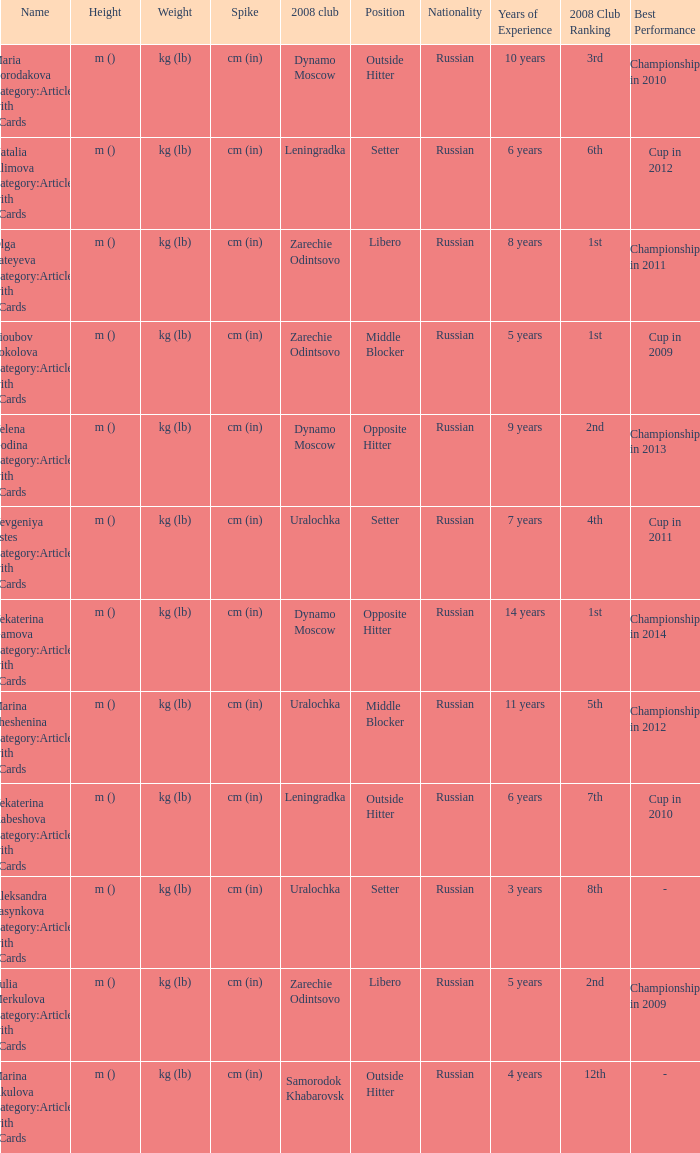What is the name when the 2008 club is uralochka? Yevgeniya Estes Category:Articles with hCards, Marina Sheshenina Category:Articles with hCards, Aleksandra Pasynkova Category:Articles with hCards. 